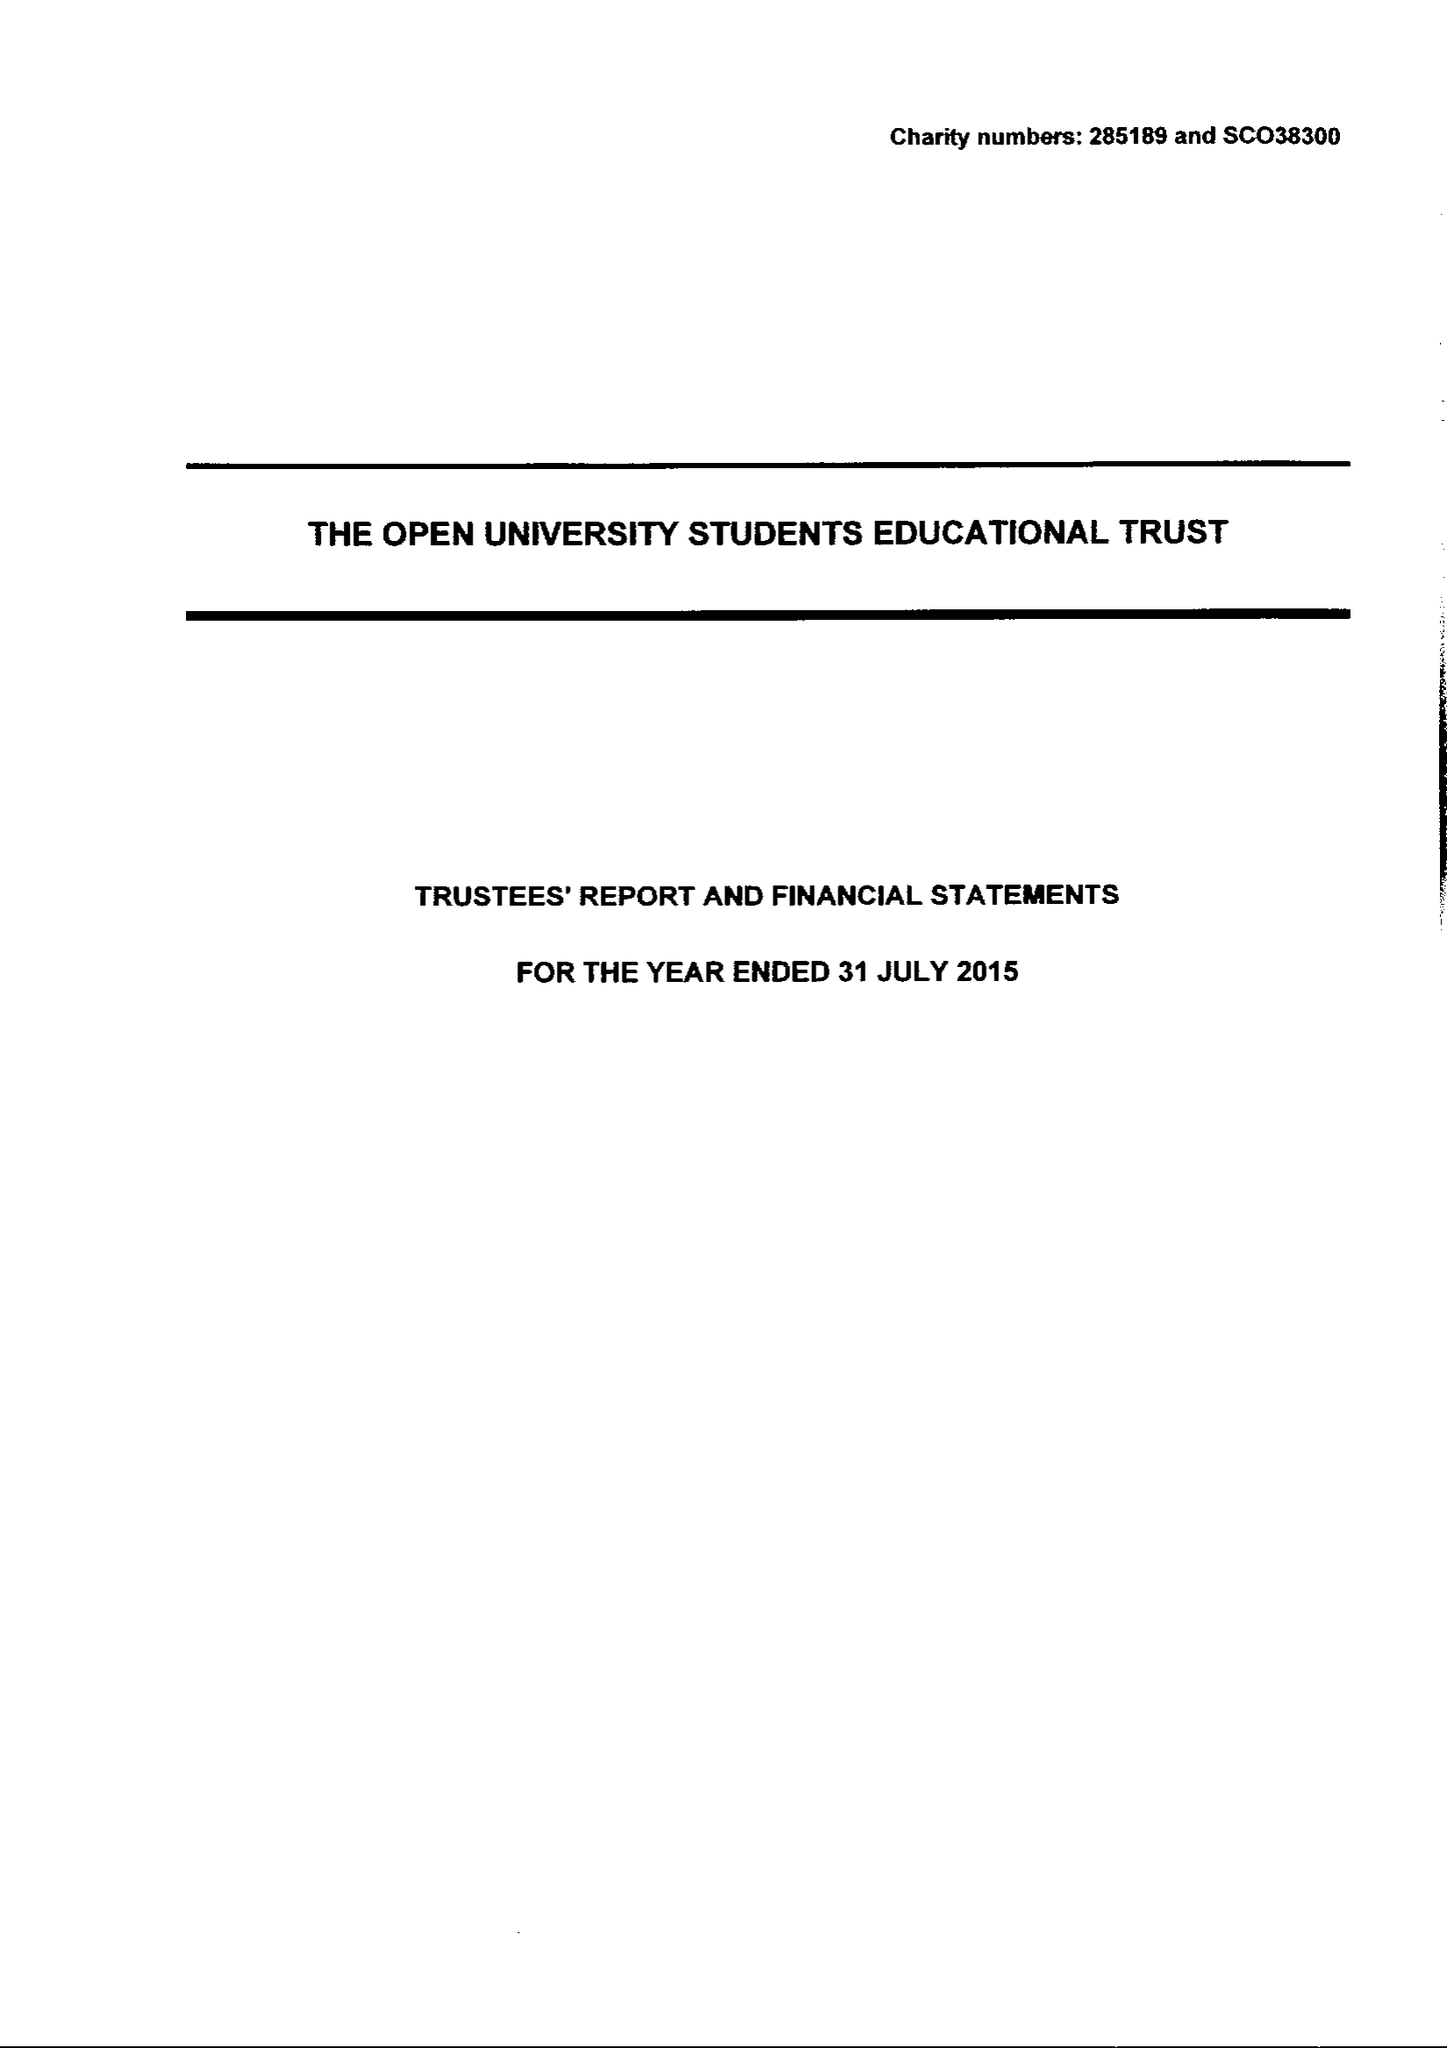What is the value for the address__post_town?
Answer the question using a single word or phrase. MILTON KEYNES 